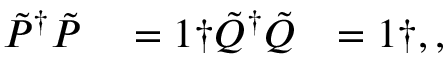<formula> <loc_0><loc_0><loc_500><loc_500>\begin{array} { r l r } { \tilde { P } ^ { \dagger } \tilde { P } } & = 1 \dag \tilde { Q } ^ { \dagger } \tilde { Q } } & { = 1 \dag , , } \end{array}</formula> 